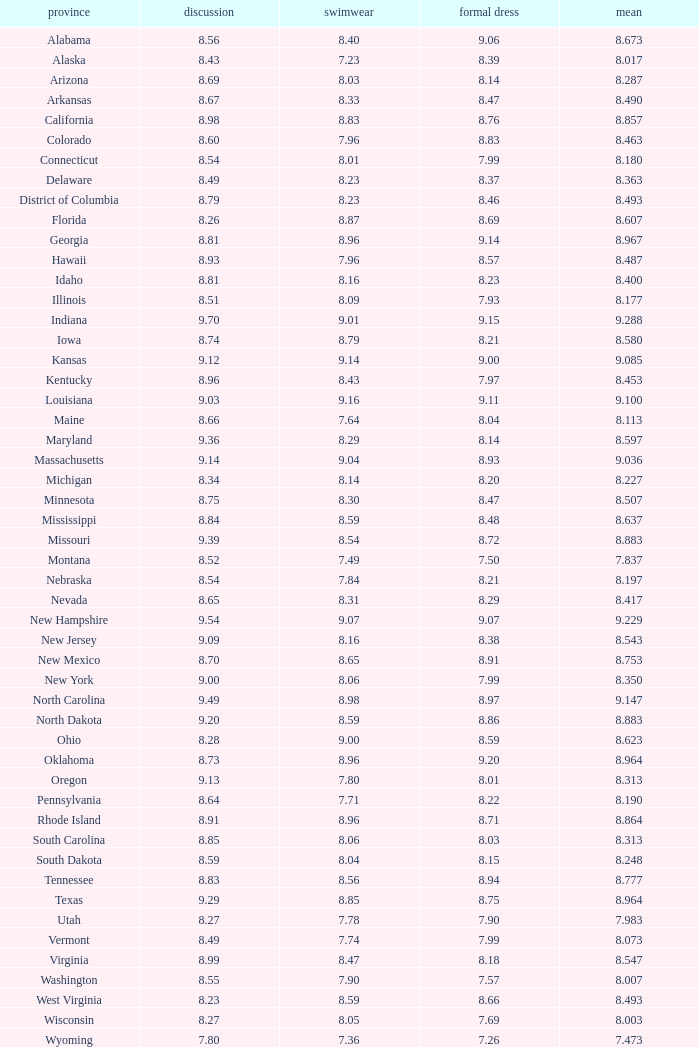Name the state with an evening gown more than 8.86 and interview less than 8.7 and swimsuit less than 8.96 Alabama. 